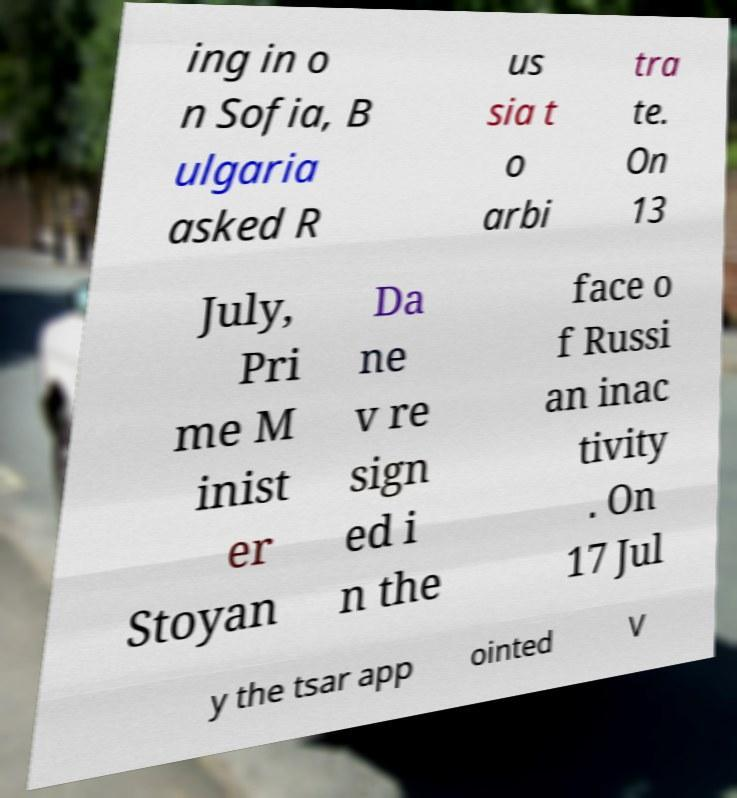For documentation purposes, I need the text within this image transcribed. Could you provide that? ing in o n Sofia, B ulgaria asked R us sia t o arbi tra te. On 13 July, Pri me M inist er Stoyan Da ne v re sign ed i n the face o f Russi an inac tivity . On 17 Jul y the tsar app ointed V 